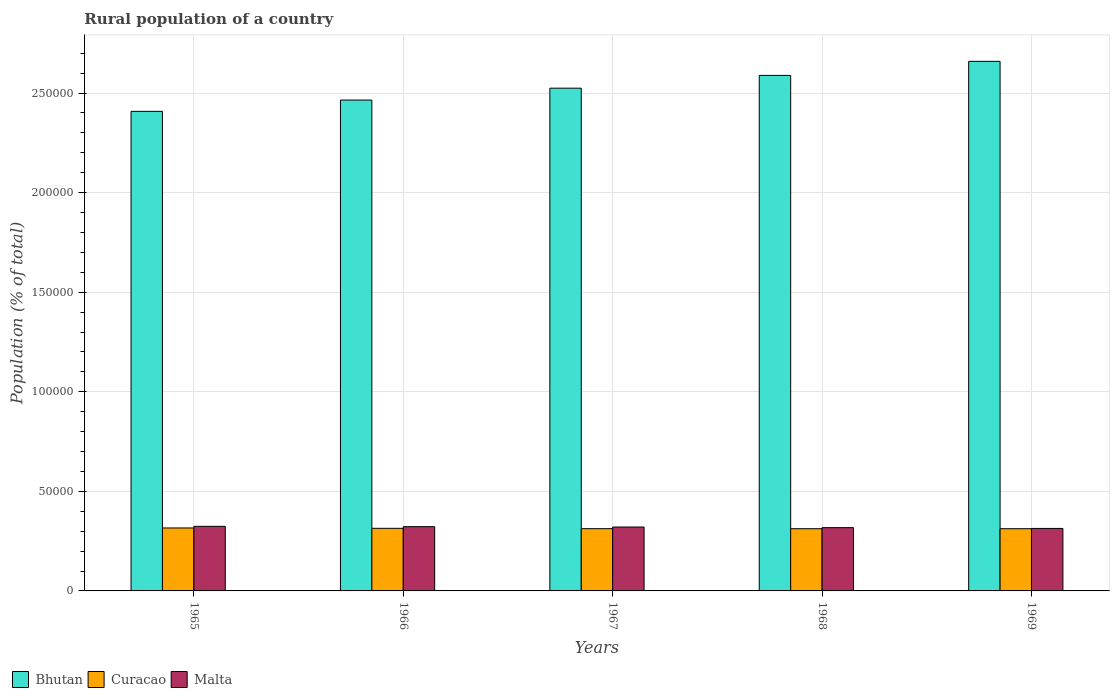How many different coloured bars are there?
Your response must be concise. 3. How many groups of bars are there?
Give a very brief answer. 5. Are the number of bars per tick equal to the number of legend labels?
Your answer should be very brief. Yes. How many bars are there on the 1st tick from the left?
Your response must be concise. 3. What is the label of the 3rd group of bars from the left?
Offer a terse response. 1967. What is the rural population in Malta in 1969?
Offer a very short reply. 3.14e+04. Across all years, what is the maximum rural population in Curacao?
Provide a short and direct response. 3.16e+04. Across all years, what is the minimum rural population in Bhutan?
Provide a succinct answer. 2.41e+05. In which year was the rural population in Bhutan maximum?
Your answer should be very brief. 1969. In which year was the rural population in Curacao minimum?
Give a very brief answer. 1969. What is the total rural population in Malta in the graph?
Offer a very short reply. 1.60e+05. What is the difference between the rural population in Malta in 1965 and that in 1968?
Your answer should be very brief. 669. What is the difference between the rural population in Bhutan in 1965 and the rural population in Malta in 1966?
Provide a short and direct response. 2.09e+05. What is the average rural population in Curacao per year?
Ensure brevity in your answer.  3.14e+04. In the year 1966, what is the difference between the rural population in Bhutan and rural population in Malta?
Ensure brevity in your answer.  2.14e+05. In how many years, is the rural population in Malta greater than 220000 %?
Give a very brief answer. 0. What is the ratio of the rural population in Bhutan in 1966 to that in 1967?
Ensure brevity in your answer.  0.98. Is the difference between the rural population in Bhutan in 1966 and 1969 greater than the difference between the rural population in Malta in 1966 and 1969?
Offer a very short reply. No. What is the difference between the highest and the second highest rural population in Bhutan?
Give a very brief answer. 7054. What is the difference between the highest and the lowest rural population in Malta?
Make the answer very short. 1065. In how many years, is the rural population in Bhutan greater than the average rural population in Bhutan taken over all years?
Provide a succinct answer. 2. Is the sum of the rural population in Malta in 1967 and 1968 greater than the maximum rural population in Curacao across all years?
Provide a succinct answer. Yes. What does the 2nd bar from the left in 1969 represents?
Your answer should be very brief. Curacao. What does the 3rd bar from the right in 1967 represents?
Make the answer very short. Bhutan. How many bars are there?
Make the answer very short. 15. Are all the bars in the graph horizontal?
Your answer should be very brief. No. How many years are there in the graph?
Provide a short and direct response. 5. Does the graph contain grids?
Offer a very short reply. Yes. How many legend labels are there?
Your response must be concise. 3. How are the legend labels stacked?
Offer a very short reply. Horizontal. What is the title of the graph?
Make the answer very short. Rural population of a country. What is the label or title of the X-axis?
Your answer should be compact. Years. What is the label or title of the Y-axis?
Your answer should be very brief. Population (% of total). What is the Population (% of total) in Bhutan in 1965?
Provide a succinct answer. 2.41e+05. What is the Population (% of total) of Curacao in 1965?
Offer a very short reply. 3.16e+04. What is the Population (% of total) of Malta in 1965?
Give a very brief answer. 3.24e+04. What is the Population (% of total) of Bhutan in 1966?
Your answer should be compact. 2.46e+05. What is the Population (% of total) in Curacao in 1966?
Your response must be concise. 3.14e+04. What is the Population (% of total) of Malta in 1966?
Make the answer very short. 3.23e+04. What is the Population (% of total) in Bhutan in 1967?
Provide a succinct answer. 2.52e+05. What is the Population (% of total) in Curacao in 1967?
Make the answer very short. 3.13e+04. What is the Population (% of total) in Malta in 1967?
Make the answer very short. 3.21e+04. What is the Population (% of total) of Bhutan in 1968?
Offer a terse response. 2.59e+05. What is the Population (% of total) in Curacao in 1968?
Keep it short and to the point. 3.12e+04. What is the Population (% of total) in Malta in 1968?
Provide a succinct answer. 3.18e+04. What is the Population (% of total) of Bhutan in 1969?
Ensure brevity in your answer.  2.66e+05. What is the Population (% of total) in Curacao in 1969?
Provide a short and direct response. 3.12e+04. What is the Population (% of total) of Malta in 1969?
Your answer should be compact. 3.14e+04. Across all years, what is the maximum Population (% of total) in Bhutan?
Offer a very short reply. 2.66e+05. Across all years, what is the maximum Population (% of total) of Curacao?
Keep it short and to the point. 3.16e+04. Across all years, what is the maximum Population (% of total) of Malta?
Ensure brevity in your answer.  3.24e+04. Across all years, what is the minimum Population (% of total) of Bhutan?
Make the answer very short. 2.41e+05. Across all years, what is the minimum Population (% of total) in Curacao?
Provide a short and direct response. 3.12e+04. Across all years, what is the minimum Population (% of total) in Malta?
Keep it short and to the point. 3.14e+04. What is the total Population (% of total) of Bhutan in the graph?
Your response must be concise. 1.26e+06. What is the total Population (% of total) of Curacao in the graph?
Keep it short and to the point. 1.57e+05. What is the total Population (% of total) of Malta in the graph?
Offer a very short reply. 1.60e+05. What is the difference between the Population (% of total) in Bhutan in 1965 and that in 1966?
Ensure brevity in your answer.  -5674. What is the difference between the Population (% of total) in Curacao in 1965 and that in 1966?
Make the answer very short. 177. What is the difference between the Population (% of total) of Malta in 1965 and that in 1966?
Ensure brevity in your answer.  174. What is the difference between the Population (% of total) of Bhutan in 1965 and that in 1967?
Your answer should be very brief. -1.16e+04. What is the difference between the Population (% of total) of Curacao in 1965 and that in 1967?
Offer a terse response. 349. What is the difference between the Population (% of total) of Malta in 1965 and that in 1967?
Your answer should be compact. 355. What is the difference between the Population (% of total) in Bhutan in 1965 and that in 1968?
Offer a terse response. -1.81e+04. What is the difference between the Population (% of total) in Curacao in 1965 and that in 1968?
Give a very brief answer. 371. What is the difference between the Population (% of total) in Malta in 1965 and that in 1968?
Your response must be concise. 669. What is the difference between the Population (% of total) of Bhutan in 1965 and that in 1969?
Offer a terse response. -2.51e+04. What is the difference between the Population (% of total) in Curacao in 1965 and that in 1969?
Ensure brevity in your answer.  375. What is the difference between the Population (% of total) of Malta in 1965 and that in 1969?
Offer a very short reply. 1065. What is the difference between the Population (% of total) in Bhutan in 1966 and that in 1967?
Offer a terse response. -5965. What is the difference between the Population (% of total) in Curacao in 1966 and that in 1967?
Offer a terse response. 172. What is the difference between the Population (% of total) of Malta in 1966 and that in 1967?
Your response must be concise. 181. What is the difference between the Population (% of total) of Bhutan in 1966 and that in 1968?
Your answer should be very brief. -1.24e+04. What is the difference between the Population (% of total) of Curacao in 1966 and that in 1968?
Provide a short and direct response. 194. What is the difference between the Population (% of total) in Malta in 1966 and that in 1968?
Offer a terse response. 495. What is the difference between the Population (% of total) in Bhutan in 1966 and that in 1969?
Offer a terse response. -1.94e+04. What is the difference between the Population (% of total) in Curacao in 1966 and that in 1969?
Ensure brevity in your answer.  198. What is the difference between the Population (% of total) in Malta in 1966 and that in 1969?
Ensure brevity in your answer.  891. What is the difference between the Population (% of total) of Bhutan in 1967 and that in 1968?
Make the answer very short. -6414. What is the difference between the Population (% of total) in Curacao in 1967 and that in 1968?
Ensure brevity in your answer.  22. What is the difference between the Population (% of total) of Malta in 1967 and that in 1968?
Give a very brief answer. 314. What is the difference between the Population (% of total) in Bhutan in 1967 and that in 1969?
Your answer should be very brief. -1.35e+04. What is the difference between the Population (% of total) of Curacao in 1967 and that in 1969?
Offer a very short reply. 26. What is the difference between the Population (% of total) of Malta in 1967 and that in 1969?
Provide a succinct answer. 710. What is the difference between the Population (% of total) of Bhutan in 1968 and that in 1969?
Your response must be concise. -7054. What is the difference between the Population (% of total) of Malta in 1968 and that in 1969?
Ensure brevity in your answer.  396. What is the difference between the Population (% of total) in Bhutan in 1965 and the Population (% of total) in Curacao in 1966?
Ensure brevity in your answer.  2.09e+05. What is the difference between the Population (% of total) in Bhutan in 1965 and the Population (% of total) in Malta in 1966?
Keep it short and to the point. 2.09e+05. What is the difference between the Population (% of total) in Curacao in 1965 and the Population (% of total) in Malta in 1966?
Keep it short and to the point. -654. What is the difference between the Population (% of total) of Bhutan in 1965 and the Population (% of total) of Curacao in 1967?
Your answer should be compact. 2.10e+05. What is the difference between the Population (% of total) of Bhutan in 1965 and the Population (% of total) of Malta in 1967?
Make the answer very short. 2.09e+05. What is the difference between the Population (% of total) of Curacao in 1965 and the Population (% of total) of Malta in 1967?
Provide a succinct answer. -473. What is the difference between the Population (% of total) in Bhutan in 1965 and the Population (% of total) in Curacao in 1968?
Your answer should be compact. 2.10e+05. What is the difference between the Population (% of total) in Bhutan in 1965 and the Population (% of total) in Malta in 1968?
Give a very brief answer. 2.09e+05. What is the difference between the Population (% of total) in Curacao in 1965 and the Population (% of total) in Malta in 1968?
Provide a short and direct response. -159. What is the difference between the Population (% of total) in Bhutan in 1965 and the Population (% of total) in Curacao in 1969?
Offer a very short reply. 2.10e+05. What is the difference between the Population (% of total) in Bhutan in 1965 and the Population (% of total) in Malta in 1969?
Your answer should be very brief. 2.09e+05. What is the difference between the Population (% of total) in Curacao in 1965 and the Population (% of total) in Malta in 1969?
Provide a succinct answer. 237. What is the difference between the Population (% of total) in Bhutan in 1966 and the Population (% of total) in Curacao in 1967?
Ensure brevity in your answer.  2.15e+05. What is the difference between the Population (% of total) in Bhutan in 1966 and the Population (% of total) in Malta in 1967?
Your answer should be compact. 2.14e+05. What is the difference between the Population (% of total) in Curacao in 1966 and the Population (% of total) in Malta in 1967?
Your answer should be very brief. -650. What is the difference between the Population (% of total) of Bhutan in 1966 and the Population (% of total) of Curacao in 1968?
Your response must be concise. 2.15e+05. What is the difference between the Population (% of total) in Bhutan in 1966 and the Population (% of total) in Malta in 1968?
Offer a very short reply. 2.15e+05. What is the difference between the Population (% of total) in Curacao in 1966 and the Population (% of total) in Malta in 1968?
Give a very brief answer. -336. What is the difference between the Population (% of total) of Bhutan in 1966 and the Population (% of total) of Curacao in 1969?
Your answer should be compact. 2.15e+05. What is the difference between the Population (% of total) of Bhutan in 1966 and the Population (% of total) of Malta in 1969?
Give a very brief answer. 2.15e+05. What is the difference between the Population (% of total) of Bhutan in 1967 and the Population (% of total) of Curacao in 1968?
Keep it short and to the point. 2.21e+05. What is the difference between the Population (% of total) in Bhutan in 1967 and the Population (% of total) in Malta in 1968?
Your answer should be compact. 2.21e+05. What is the difference between the Population (% of total) of Curacao in 1967 and the Population (% of total) of Malta in 1968?
Your response must be concise. -508. What is the difference between the Population (% of total) in Bhutan in 1967 and the Population (% of total) in Curacao in 1969?
Make the answer very short. 2.21e+05. What is the difference between the Population (% of total) of Bhutan in 1967 and the Population (% of total) of Malta in 1969?
Offer a terse response. 2.21e+05. What is the difference between the Population (% of total) in Curacao in 1967 and the Population (% of total) in Malta in 1969?
Make the answer very short. -112. What is the difference between the Population (% of total) in Bhutan in 1968 and the Population (% of total) in Curacao in 1969?
Ensure brevity in your answer.  2.28e+05. What is the difference between the Population (% of total) of Bhutan in 1968 and the Population (% of total) of Malta in 1969?
Offer a very short reply. 2.27e+05. What is the difference between the Population (% of total) of Curacao in 1968 and the Population (% of total) of Malta in 1969?
Your answer should be compact. -134. What is the average Population (% of total) in Bhutan per year?
Provide a succinct answer. 2.53e+05. What is the average Population (% of total) of Curacao per year?
Provide a succinct answer. 3.14e+04. What is the average Population (% of total) of Malta per year?
Your answer should be very brief. 3.20e+04. In the year 1965, what is the difference between the Population (% of total) of Bhutan and Population (% of total) of Curacao?
Offer a terse response. 2.09e+05. In the year 1965, what is the difference between the Population (% of total) in Bhutan and Population (% of total) in Malta?
Offer a very short reply. 2.08e+05. In the year 1965, what is the difference between the Population (% of total) of Curacao and Population (% of total) of Malta?
Your answer should be very brief. -828. In the year 1966, what is the difference between the Population (% of total) in Bhutan and Population (% of total) in Curacao?
Give a very brief answer. 2.15e+05. In the year 1966, what is the difference between the Population (% of total) of Bhutan and Population (% of total) of Malta?
Give a very brief answer. 2.14e+05. In the year 1966, what is the difference between the Population (% of total) of Curacao and Population (% of total) of Malta?
Keep it short and to the point. -831. In the year 1967, what is the difference between the Population (% of total) of Bhutan and Population (% of total) of Curacao?
Your response must be concise. 2.21e+05. In the year 1967, what is the difference between the Population (% of total) of Bhutan and Population (% of total) of Malta?
Provide a short and direct response. 2.20e+05. In the year 1967, what is the difference between the Population (% of total) in Curacao and Population (% of total) in Malta?
Give a very brief answer. -822. In the year 1968, what is the difference between the Population (% of total) of Bhutan and Population (% of total) of Curacao?
Your response must be concise. 2.28e+05. In the year 1968, what is the difference between the Population (% of total) in Bhutan and Population (% of total) in Malta?
Provide a short and direct response. 2.27e+05. In the year 1968, what is the difference between the Population (% of total) of Curacao and Population (% of total) of Malta?
Ensure brevity in your answer.  -530. In the year 1969, what is the difference between the Population (% of total) of Bhutan and Population (% of total) of Curacao?
Ensure brevity in your answer.  2.35e+05. In the year 1969, what is the difference between the Population (% of total) of Bhutan and Population (% of total) of Malta?
Your answer should be very brief. 2.35e+05. In the year 1969, what is the difference between the Population (% of total) of Curacao and Population (% of total) of Malta?
Provide a short and direct response. -138. What is the ratio of the Population (% of total) of Bhutan in 1965 to that in 1966?
Keep it short and to the point. 0.98. What is the ratio of the Population (% of total) of Curacao in 1965 to that in 1966?
Offer a very short reply. 1.01. What is the ratio of the Population (% of total) in Malta in 1965 to that in 1966?
Your response must be concise. 1.01. What is the ratio of the Population (% of total) of Bhutan in 1965 to that in 1967?
Your answer should be compact. 0.95. What is the ratio of the Population (% of total) in Curacao in 1965 to that in 1967?
Your response must be concise. 1.01. What is the ratio of the Population (% of total) in Malta in 1965 to that in 1967?
Ensure brevity in your answer.  1.01. What is the ratio of the Population (% of total) of Bhutan in 1965 to that in 1968?
Make the answer very short. 0.93. What is the ratio of the Population (% of total) in Curacao in 1965 to that in 1968?
Provide a short and direct response. 1.01. What is the ratio of the Population (% of total) of Malta in 1965 to that in 1968?
Offer a very short reply. 1.02. What is the ratio of the Population (% of total) of Bhutan in 1965 to that in 1969?
Give a very brief answer. 0.91. What is the ratio of the Population (% of total) of Malta in 1965 to that in 1969?
Offer a terse response. 1.03. What is the ratio of the Population (% of total) of Bhutan in 1966 to that in 1967?
Your response must be concise. 0.98. What is the ratio of the Population (% of total) in Malta in 1966 to that in 1967?
Provide a succinct answer. 1.01. What is the ratio of the Population (% of total) of Bhutan in 1966 to that in 1968?
Your response must be concise. 0.95. What is the ratio of the Population (% of total) of Curacao in 1966 to that in 1968?
Offer a very short reply. 1.01. What is the ratio of the Population (% of total) in Malta in 1966 to that in 1968?
Provide a succinct answer. 1.02. What is the ratio of the Population (% of total) in Bhutan in 1966 to that in 1969?
Your answer should be compact. 0.93. What is the ratio of the Population (% of total) of Malta in 1966 to that in 1969?
Your answer should be very brief. 1.03. What is the ratio of the Population (% of total) in Bhutan in 1967 to that in 1968?
Offer a very short reply. 0.98. What is the ratio of the Population (% of total) of Malta in 1967 to that in 1968?
Provide a succinct answer. 1.01. What is the ratio of the Population (% of total) in Bhutan in 1967 to that in 1969?
Offer a terse response. 0.95. What is the ratio of the Population (% of total) in Curacao in 1967 to that in 1969?
Provide a short and direct response. 1. What is the ratio of the Population (% of total) in Malta in 1967 to that in 1969?
Offer a terse response. 1.02. What is the ratio of the Population (% of total) of Bhutan in 1968 to that in 1969?
Offer a terse response. 0.97. What is the ratio of the Population (% of total) of Curacao in 1968 to that in 1969?
Your answer should be very brief. 1. What is the ratio of the Population (% of total) of Malta in 1968 to that in 1969?
Offer a terse response. 1.01. What is the difference between the highest and the second highest Population (% of total) in Bhutan?
Provide a succinct answer. 7054. What is the difference between the highest and the second highest Population (% of total) of Curacao?
Make the answer very short. 177. What is the difference between the highest and the second highest Population (% of total) in Malta?
Your answer should be very brief. 174. What is the difference between the highest and the lowest Population (% of total) of Bhutan?
Keep it short and to the point. 2.51e+04. What is the difference between the highest and the lowest Population (% of total) in Curacao?
Your response must be concise. 375. What is the difference between the highest and the lowest Population (% of total) of Malta?
Your response must be concise. 1065. 